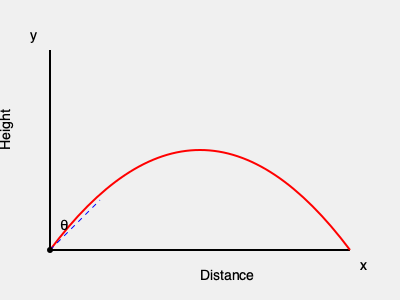You're practicing your cricket bowling skills, aiming to perfect your trajectory for the upcoming street cricket tournament. If you release the ball with an initial velocity of 30 m/s at an angle of 45° to the horizontal, how far will the ball travel horizontally before hitting the ground? Assume there's no air resistance and use g = 9.8 m/s². To solve this problem, we'll use the equations of projectile motion:

1) First, let's break down the initial velocity into its horizontal and vertical components:
   $v_x = v \cos \theta = 30 \cos 45° = 30 \cdot \frac{\sqrt{2}}{2} \approx 21.21$ m/s
   $v_y = v \sin \theta = 30 \sin 45° = 30 \cdot \frac{\sqrt{2}}{2} \approx 21.21$ m/s

2) The time of flight can be calculated using the vertical motion equation:
   $y = v_y t - \frac{1}{2}gt^2$
   At the highest point, $y = 0$, so:
   $0 = 21.21t - 4.9t^2$
   $t = \frac{21.21}{4.9} \approx 4.33$ seconds (this is the time to reach the highest point)

3) The total time of flight is twice this value:
   $T = 2t \approx 8.66$ seconds

4) Now, we can use the horizontal motion equation to find the distance:
   $x = v_x T$
   $x = 21.21 \cdot 8.66 \approx 183.68$ meters

Therefore, the ball will travel approximately 183.68 meters horizontally before hitting the ground.
Answer: 183.68 meters 